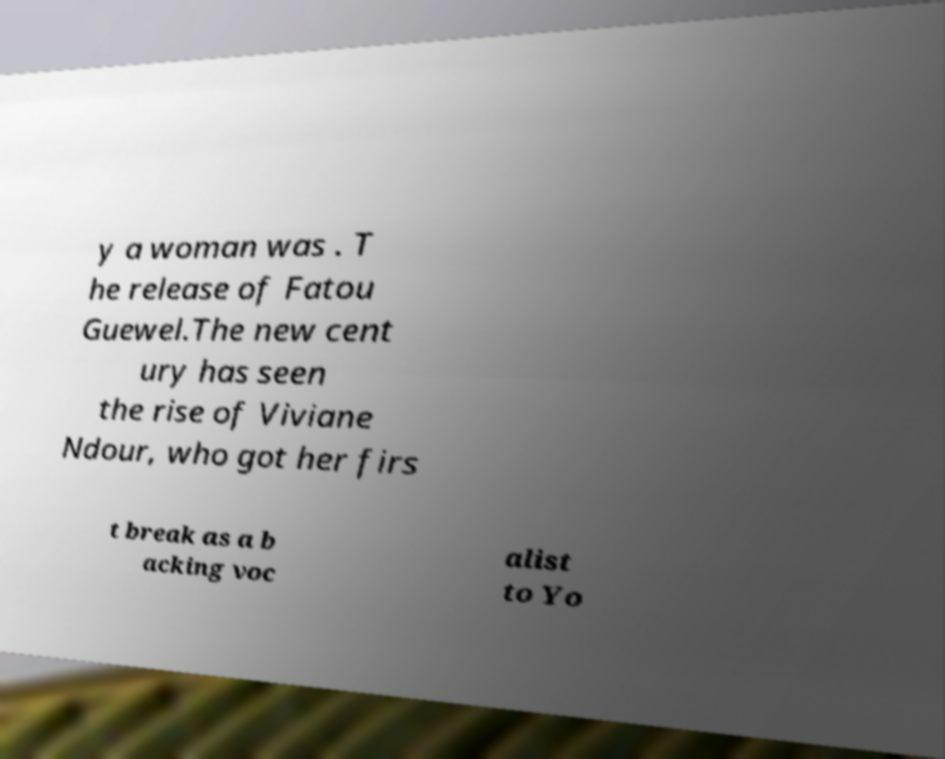For documentation purposes, I need the text within this image transcribed. Could you provide that? y a woman was . T he release of Fatou Guewel.The new cent ury has seen the rise of Viviane Ndour, who got her firs t break as a b acking voc alist to Yo 